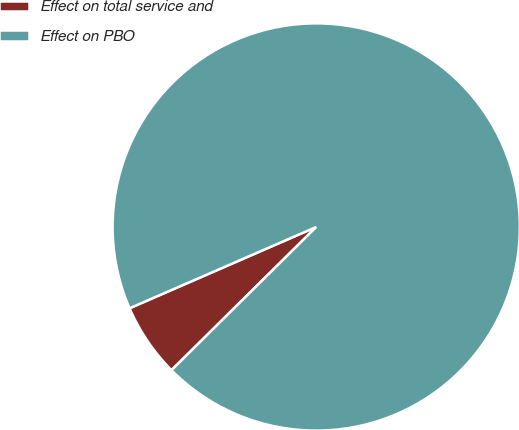Convert chart to OTSL. <chart><loc_0><loc_0><loc_500><loc_500><pie_chart><fcel>Effect on total service and<fcel>Effect on PBO<nl><fcel>5.88%<fcel>94.12%<nl></chart> 